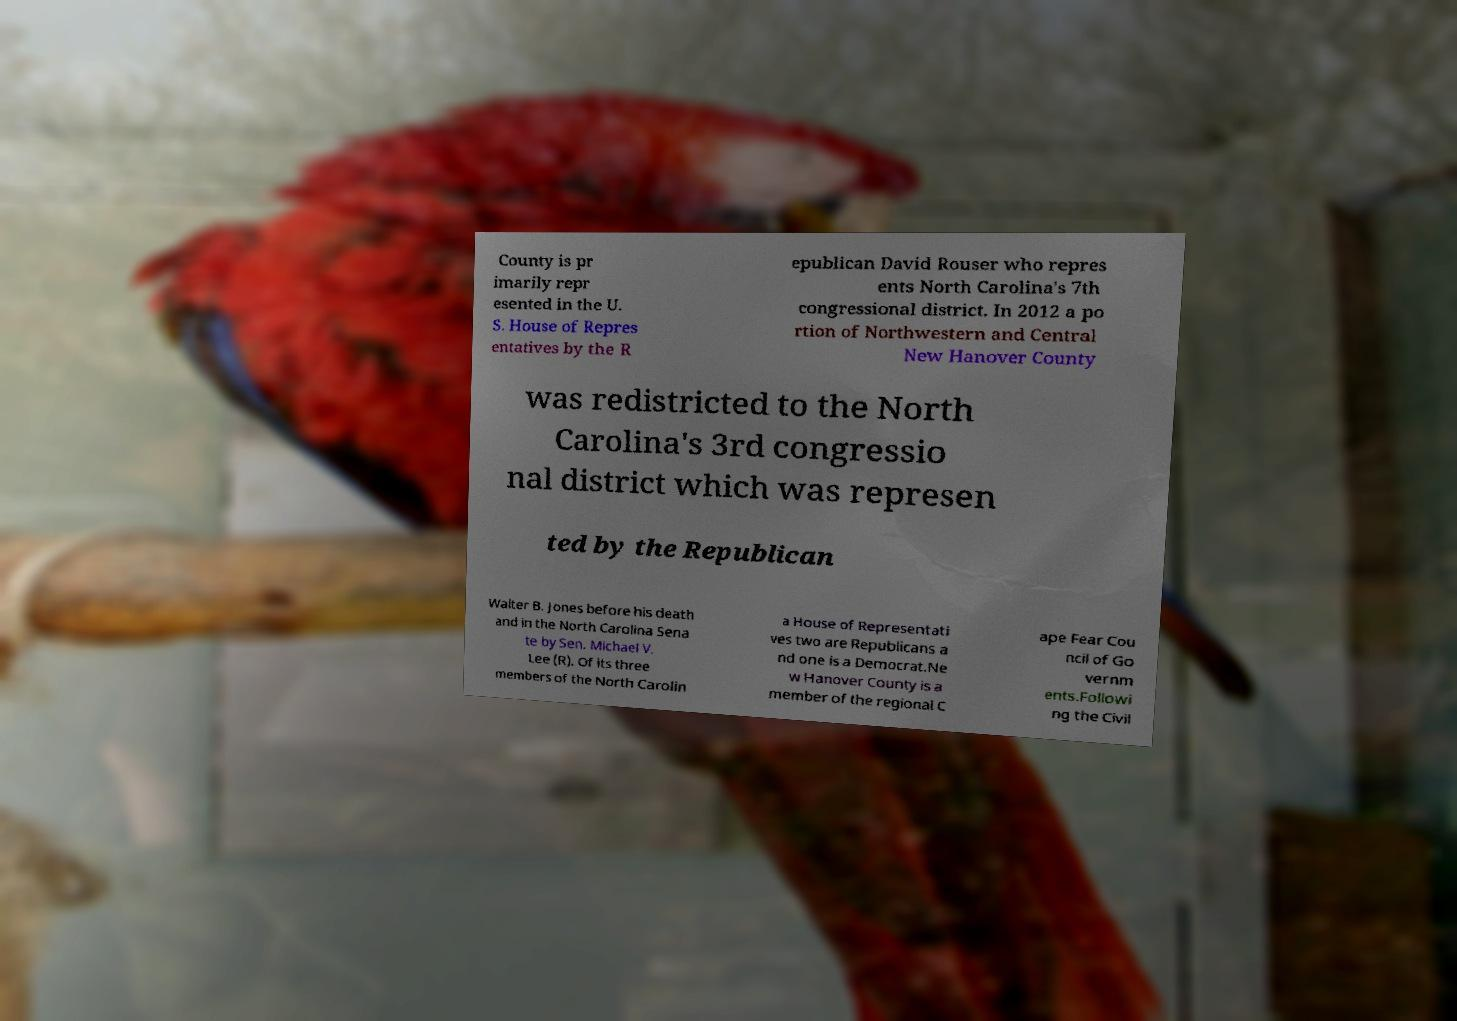I need the written content from this picture converted into text. Can you do that? County is pr imarily repr esented in the U. S. House of Repres entatives by the R epublican David Rouser who repres ents North Carolina's 7th congressional district. In 2012 a po rtion of Northwestern and Central New Hanover County was redistricted to the North Carolina's 3rd congressio nal district which was represen ted by the Republican Walter B. Jones before his death and in the North Carolina Sena te by Sen. Michael V. Lee (R). Of its three members of the North Carolin a House of Representati ves two are Republicans a nd one is a Democrat.Ne w Hanover County is a member of the regional C ape Fear Cou ncil of Go vernm ents.Followi ng the Civil 